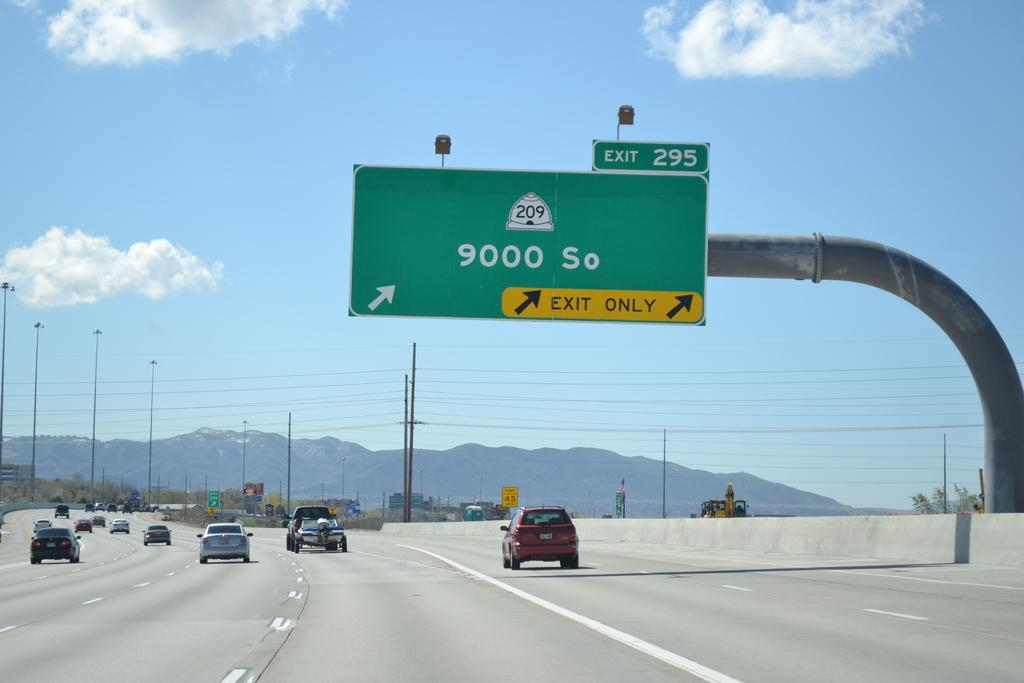<image>
Share a concise interpretation of the image provided. Green and yellow highway sign that says 9000 So. 